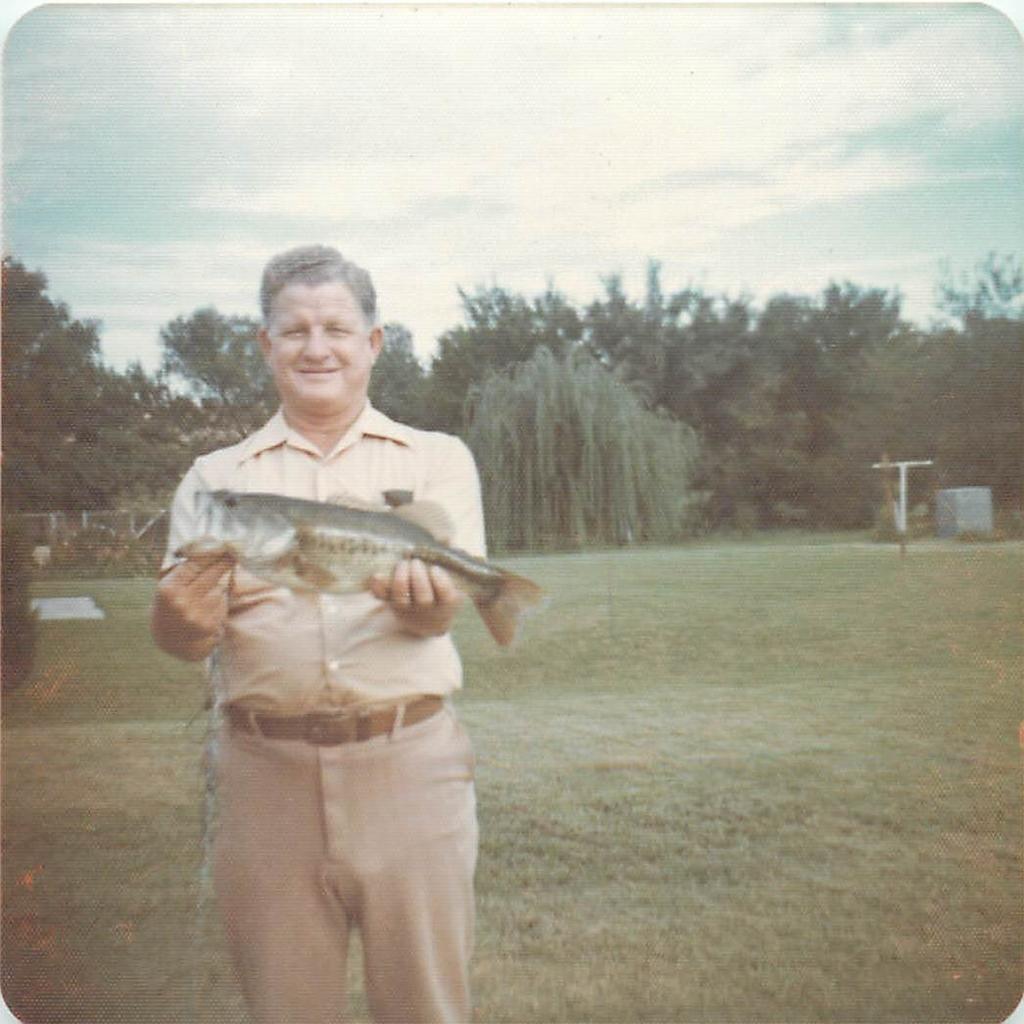Could you give a brief overview of what you see in this image? This is an outside view. On the left side I can see a man standing, holding a fish in the hands and giving pose for the picture. At the bottom I can see the grass. In the background there are some trees. At the top I can see the sky. 